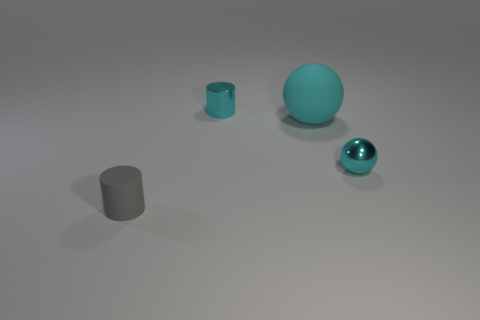Add 4 small gray objects. How many small gray objects are left? 5 Add 3 shiny balls. How many shiny balls exist? 4 Add 3 tiny brown metal balls. How many objects exist? 7 Subtract 0 purple spheres. How many objects are left? 4 Subtract all gray cylinders. Subtract all brown spheres. How many cylinders are left? 1 Subtract all gray blocks. How many brown cylinders are left? 0 Subtract all tiny cyan shiny cubes. Subtract all tiny things. How many objects are left? 1 